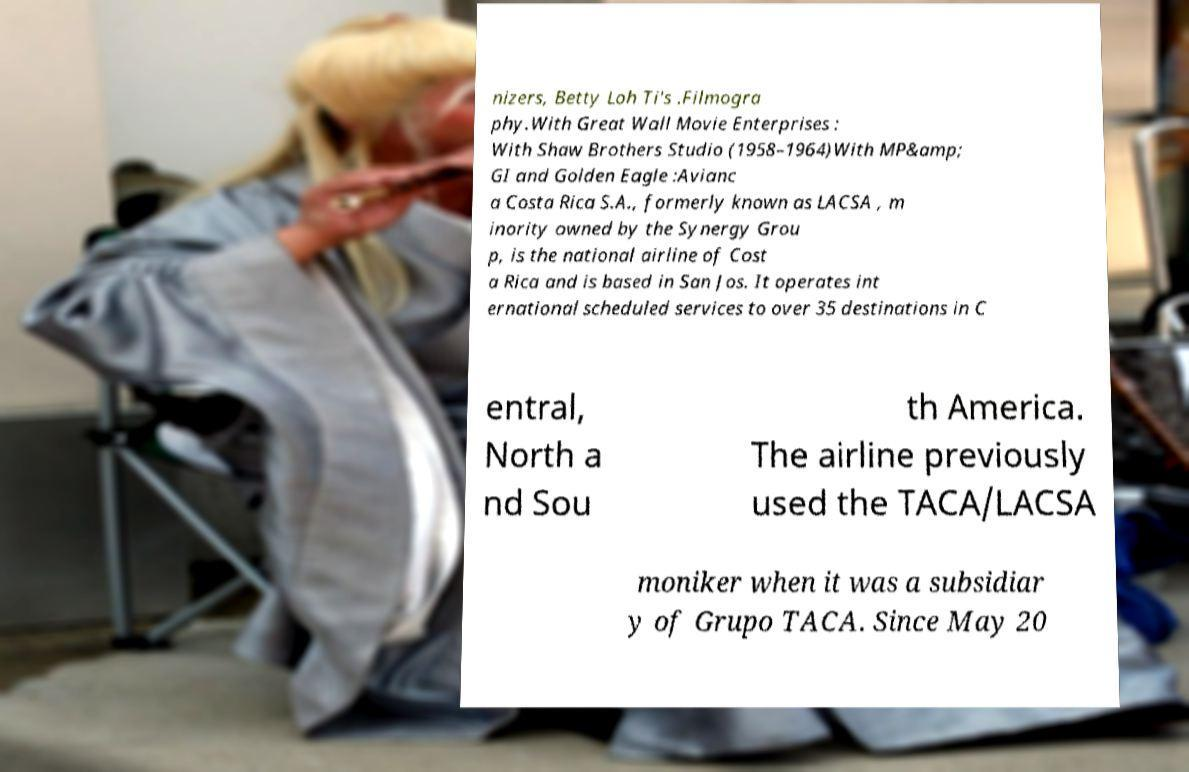Can you accurately transcribe the text from the provided image for me? nizers, Betty Loh Ti's .Filmogra phy.With Great Wall Movie Enterprises : With Shaw Brothers Studio (1958–1964)With MP&amp; GI and Golden Eagle :Avianc a Costa Rica S.A., formerly known as LACSA , m inority owned by the Synergy Grou p, is the national airline of Cost a Rica and is based in San Jos. It operates int ernational scheduled services to over 35 destinations in C entral, North a nd Sou th America. The airline previously used the TACA/LACSA moniker when it was a subsidiar y of Grupo TACA. Since May 20 